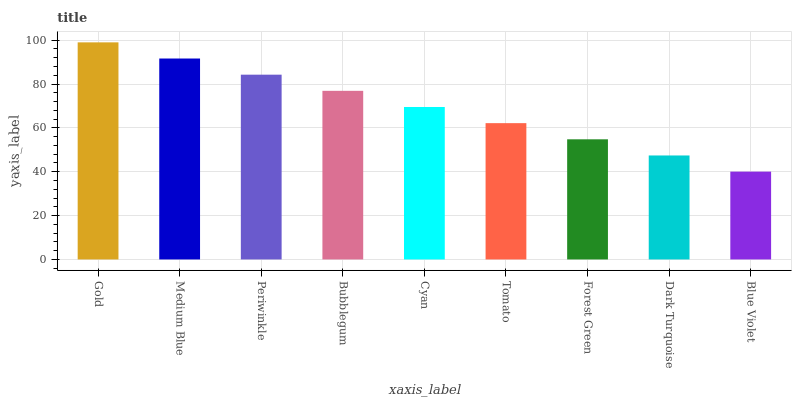Is Blue Violet the minimum?
Answer yes or no. Yes. Is Gold the maximum?
Answer yes or no. Yes. Is Medium Blue the minimum?
Answer yes or no. No. Is Medium Blue the maximum?
Answer yes or no. No. Is Gold greater than Medium Blue?
Answer yes or no. Yes. Is Medium Blue less than Gold?
Answer yes or no. Yes. Is Medium Blue greater than Gold?
Answer yes or no. No. Is Gold less than Medium Blue?
Answer yes or no. No. Is Cyan the high median?
Answer yes or no. Yes. Is Cyan the low median?
Answer yes or no. Yes. Is Gold the high median?
Answer yes or no. No. Is Periwinkle the low median?
Answer yes or no. No. 